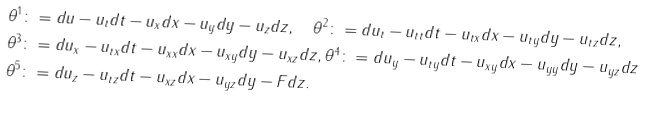Convert formula to latex. <formula><loc_0><loc_0><loc_500><loc_500>\theta ^ { 1 } & \colon = d u - u _ { t } d t - u _ { x } d x - u _ { y } d y - u _ { z } d z , \quad \theta ^ { 2 } \colon = d u _ { t } - u _ { t t } d t - u _ { t x } d x - u _ { t y } d y - u _ { t z } d z , \\ \theta ^ { 3 } & \colon = d u _ { x } - u _ { t x } d t - u _ { x x } d x - u _ { x y } d y - u _ { x z } d z , \theta ^ { 4 } \colon = d u _ { y } - u _ { t y } d t - u _ { x y } d x - u _ { y y } d y - u _ { y z } d z \\ \theta ^ { 5 } & \colon = d u _ { z } - u _ { t z } d t - u _ { x z } d x - u _ { y z } d y - F d z .</formula> 